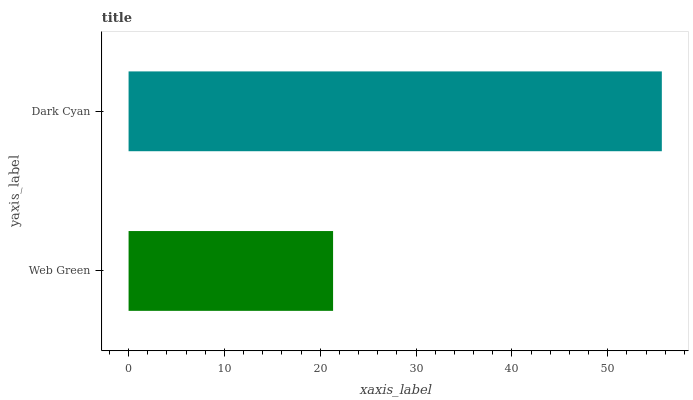Is Web Green the minimum?
Answer yes or no. Yes. Is Dark Cyan the maximum?
Answer yes or no. Yes. Is Dark Cyan the minimum?
Answer yes or no. No. Is Dark Cyan greater than Web Green?
Answer yes or no. Yes. Is Web Green less than Dark Cyan?
Answer yes or no. Yes. Is Web Green greater than Dark Cyan?
Answer yes or no. No. Is Dark Cyan less than Web Green?
Answer yes or no. No. Is Dark Cyan the high median?
Answer yes or no. Yes. Is Web Green the low median?
Answer yes or no. Yes. Is Web Green the high median?
Answer yes or no. No. Is Dark Cyan the low median?
Answer yes or no. No. 